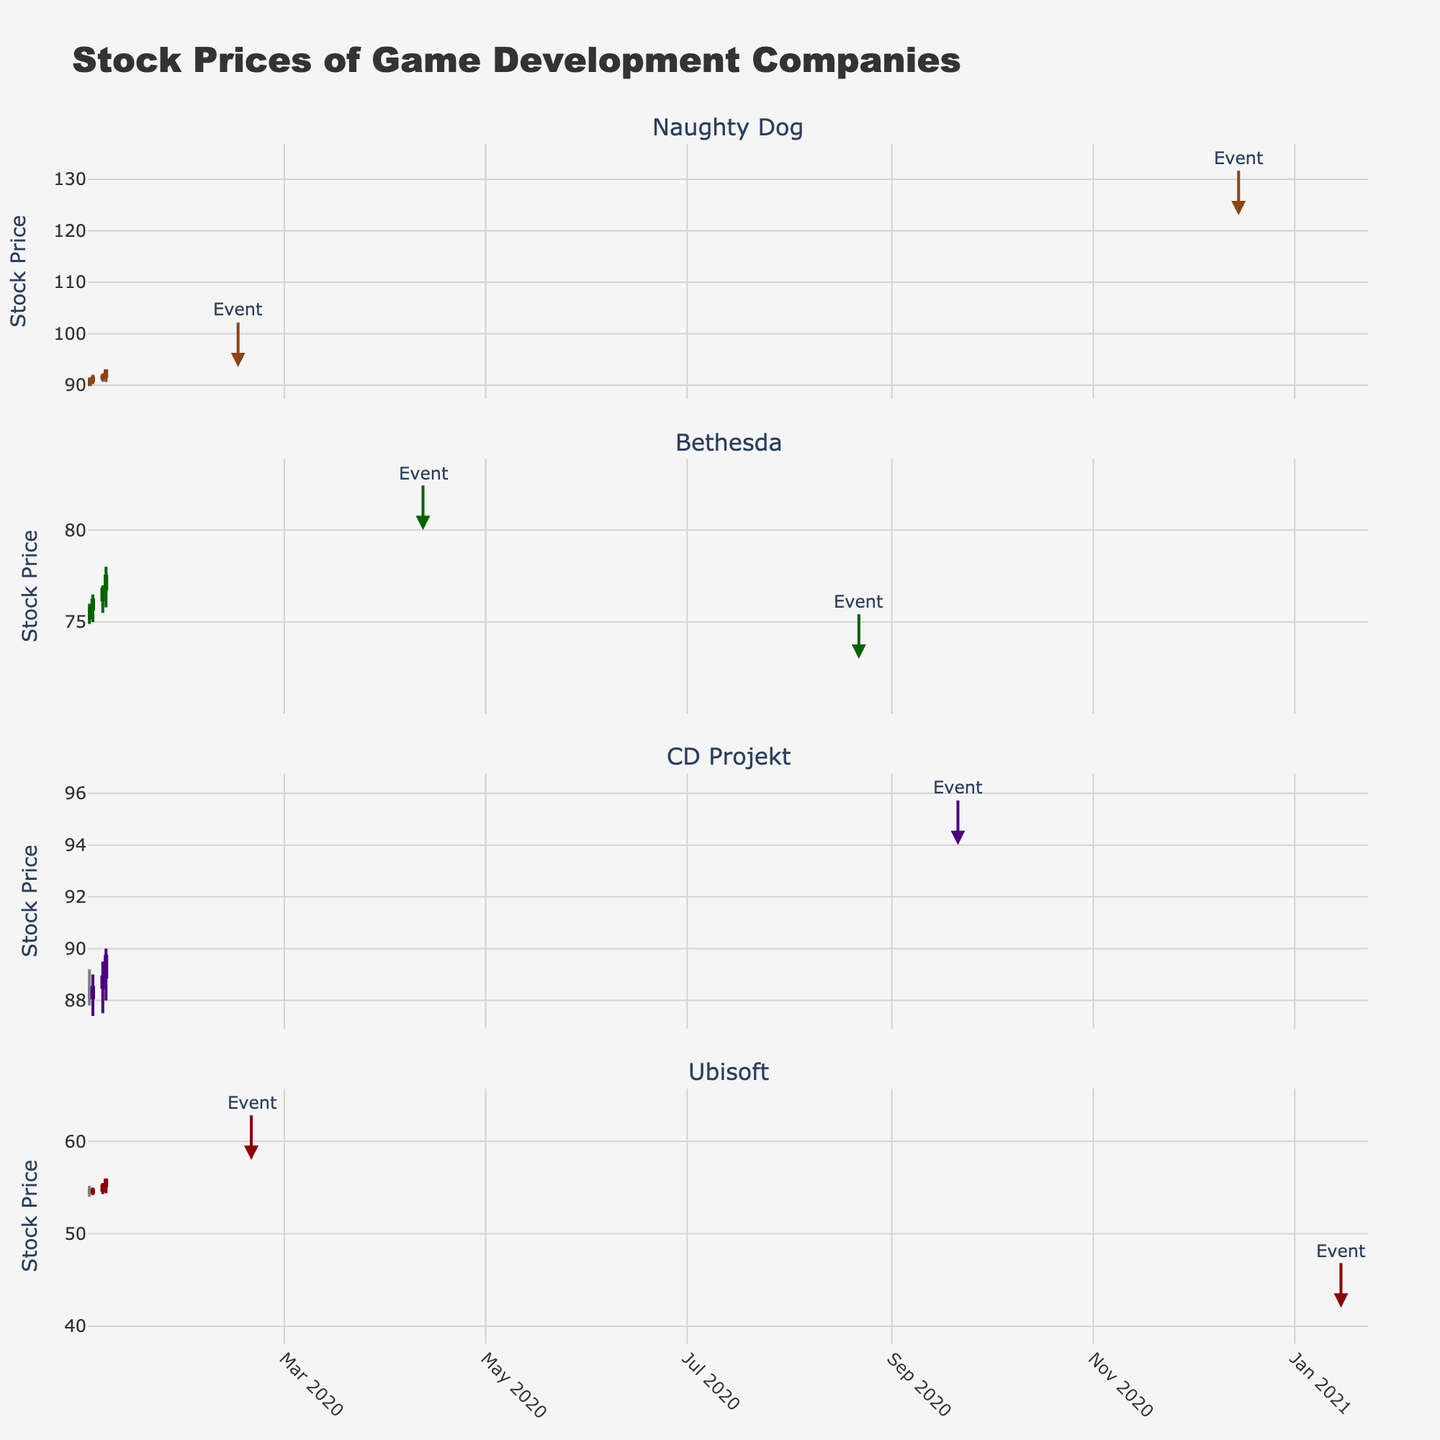How many companies' stock prices are visualized in the plot? The subplot titles indicate the number of companies. Each subplot title corresponds to a different company.
Answer: 4 What is the color used for increasing stock prices of Naughty Dog? Observe the line colors for increasing candlesticks in the Naughty Dog subplot. The color is brown.
Answer: Brown Did Naughty Dog's stock price increase or decrease after the announcement of The Last of Us TV adaptation on February 16, 2020? Identify the candlestick on February 16, 2020. The close price is lower than the open price, indicating a decrease.
Answer: Decrease What was the closing price of CD Projekt on September 21, 2020, the day they announced Cyberpunk: Edgerunners? Find the candlestick on September 21, 2020, and look at the closing price.
Answer: 93.5 Which company's stock showed a notable decline after a TV adaptation was poorly received, and when did this happen? Check the annotations for 'Event' and correlate with candlesticks showing large downward movements. The notable case is Bethesda on August 22, 2020, and Ubisoft on January 15, 2021.
Answer: Bethesda (August 22, 2020) and Ubisoft (January 15, 2021) Compare the stock price changes of Naughty Dog and Bethesda immediately after their TV adaptation announcements. Which company showed a more positive trend? Locate the candlesticks for announcement dates. Compare the trends over the subsequent days. Naughty Dog shows a minor decline, while Bethesda’s prices initially increased.
Answer: Bethesda What is the time span of the stock prices visualized in the plot? Observe the x-axis of each subplot to identify the start and end dates.
Answer: January 2020 to January 2021 Calculating the average stock price for Ubisoft in the week before and after The Division TV adaptation announcement on February 20, 2020. Did the announcement have a noticeable effect? Sum and average the closing prices from February 13-19, then from February 20-27. Compare the averages.
Answer: Yes, it increased from 54.7 to 57.0 How did CD Projekt's stock price trend after the announcement of Cyberpunk: Edgerunners? Observe the candlestick pattern after September 21, 2020. The stock price shows a generally upward trend.
Answer: Upward trend Between Naughty Dog and Ubisoft, which company's stock had a higher peak close price during the entire period? Identify and compare the highest close prices in the respective candlestick subplots. Ubisoft's is lower, while Naughty Dog reached roughly 123.
Answer: Naughty Dog 